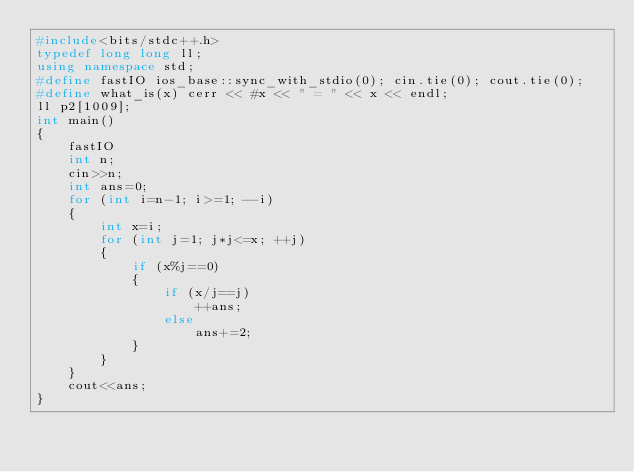<code> <loc_0><loc_0><loc_500><loc_500><_C++_>#include<bits/stdc++.h>
typedef long long ll;
using namespace std;
#define fastIO ios_base::sync_with_stdio(0); cin.tie(0); cout.tie(0);
#define what_is(x) cerr << #x << " = " << x << endl;
ll p2[1009];
int main()
{
    fastIO
    int n;
    cin>>n;
    int ans=0;
    for (int i=n-1; i>=1; --i)
    {
        int x=i;
        for (int j=1; j*j<=x; ++j)
        {
            if (x%j==0)
            {
                if (x/j==j)
                    ++ans;
                else
                    ans+=2;
            }
        }
    }
    cout<<ans;
}
</code> 